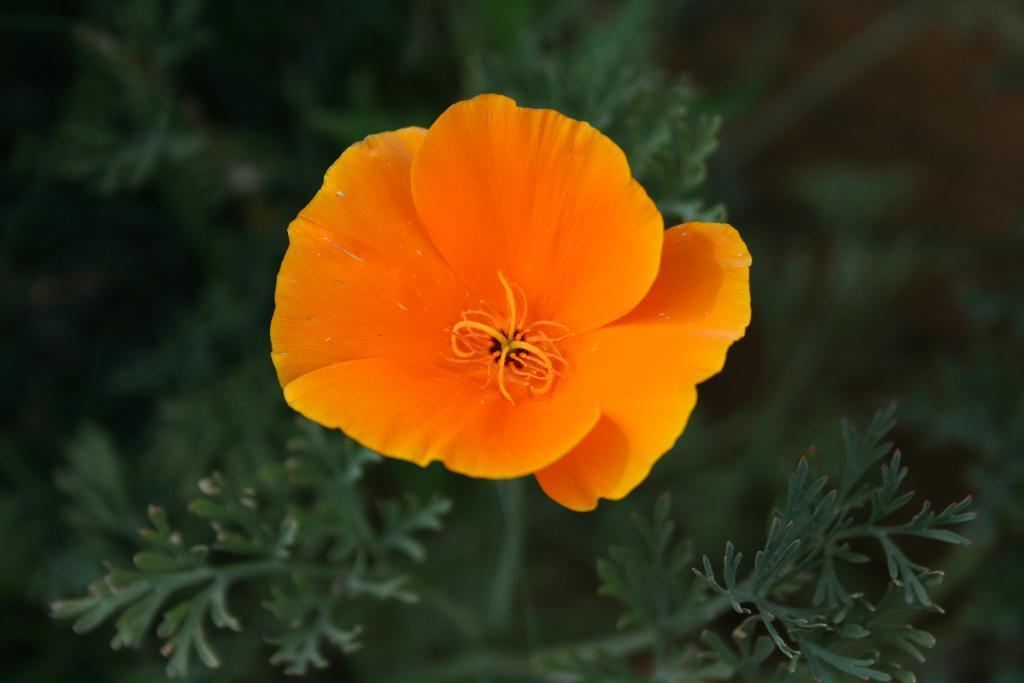Describe this image in one or two sentences. It is a beautiful flower in orange color, these are the leaves of a plant. 